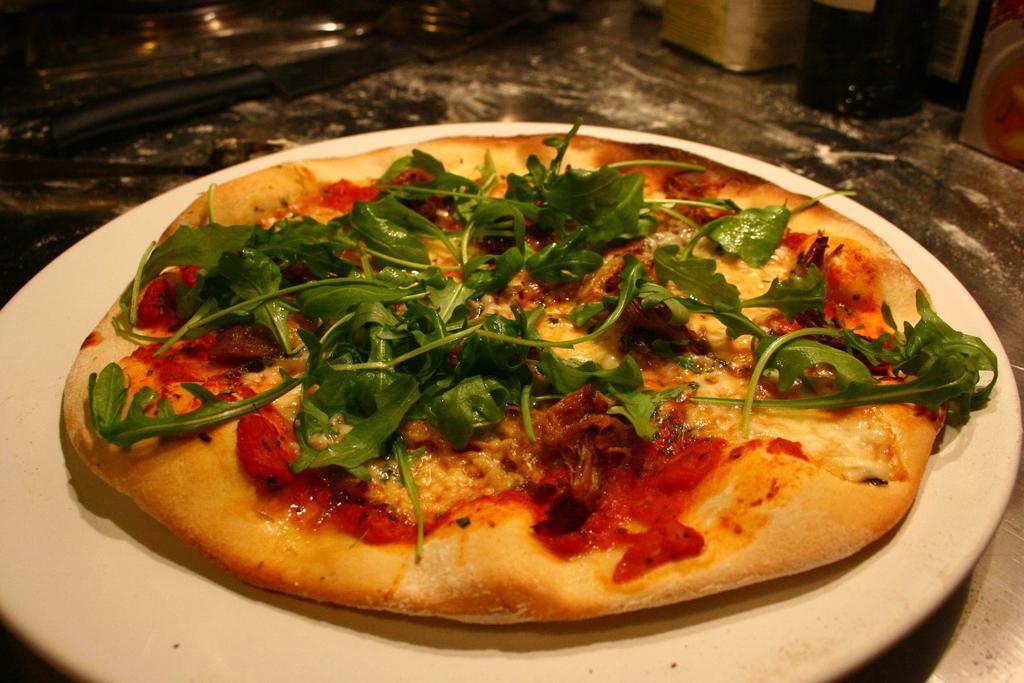In one or two sentences, can you explain what this image depicts? In the foreground of this image, there is a pizza with green leaves on it is on a platter. At the top, there is a knife and few objects on the surface. 